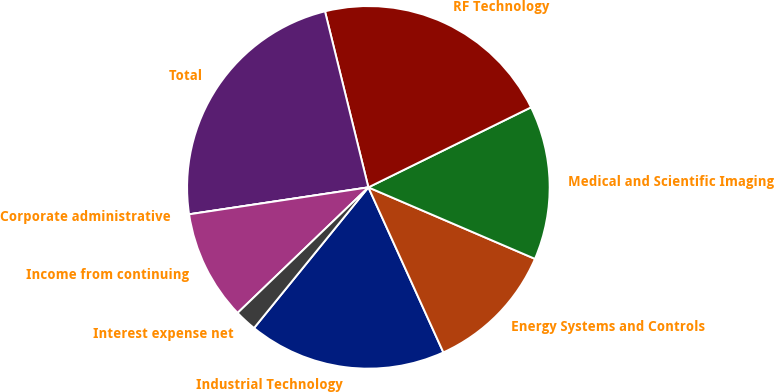Convert chart. <chart><loc_0><loc_0><loc_500><loc_500><pie_chart><fcel>Industrial Technology<fcel>Energy Systems and Controls<fcel>Medical and Scientific Imaging<fcel>RF Technology<fcel>Total<fcel>Corporate administrative<fcel>Income from continuing<fcel>Interest expense net<nl><fcel>17.65%<fcel>11.76%<fcel>13.73%<fcel>21.57%<fcel>23.53%<fcel>0.0%<fcel>9.8%<fcel>1.96%<nl></chart> 